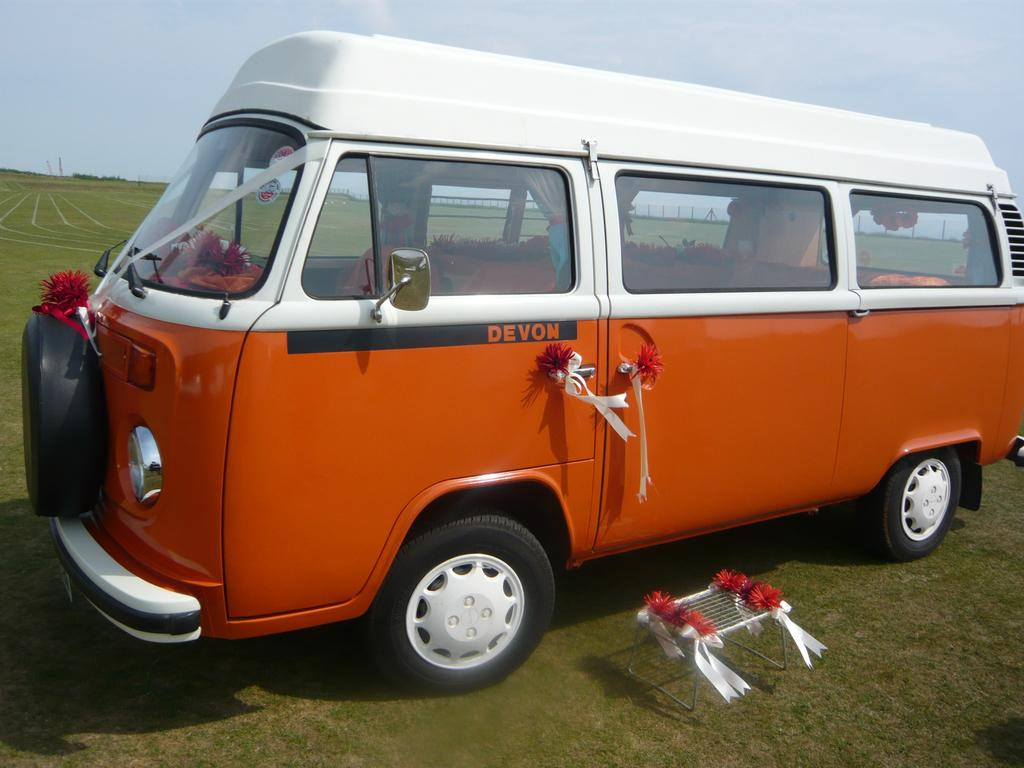<image>
Create a compact narrative representing the image presented. An older style van, that was popular in the 70's, has bows on the front and on the driver side door, under the word Devon. 